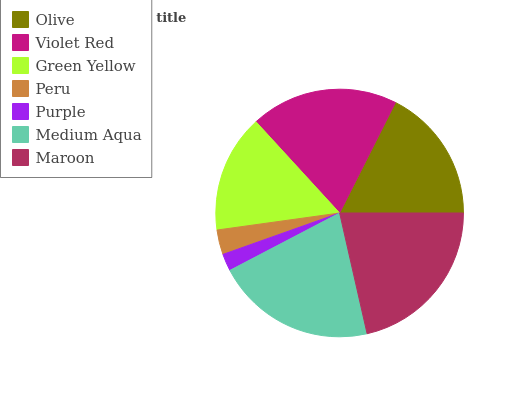Is Purple the minimum?
Answer yes or no. Yes. Is Maroon the maximum?
Answer yes or no. Yes. Is Violet Red the minimum?
Answer yes or no. No. Is Violet Red the maximum?
Answer yes or no. No. Is Violet Red greater than Olive?
Answer yes or no. Yes. Is Olive less than Violet Red?
Answer yes or no. Yes. Is Olive greater than Violet Red?
Answer yes or no. No. Is Violet Red less than Olive?
Answer yes or no. No. Is Olive the high median?
Answer yes or no. Yes. Is Olive the low median?
Answer yes or no. Yes. Is Medium Aqua the high median?
Answer yes or no. No. Is Peru the low median?
Answer yes or no. No. 